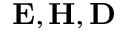Convert formula to latex. <formula><loc_0><loc_0><loc_500><loc_500>E , H , D</formula> 